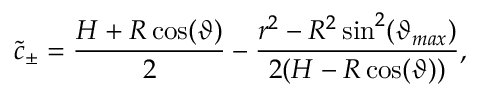Convert formula to latex. <formula><loc_0><loc_0><loc_500><loc_500>\tilde { c } _ { \pm } = \frac { H + R \cos ( \vartheta ) } { 2 } - \frac { r ^ { 2 } - R ^ { 2 } \sin ^ { 2 } ( \vartheta _ { \max } ) } { 2 ( H - R \cos ( \vartheta ) ) } ,</formula> 